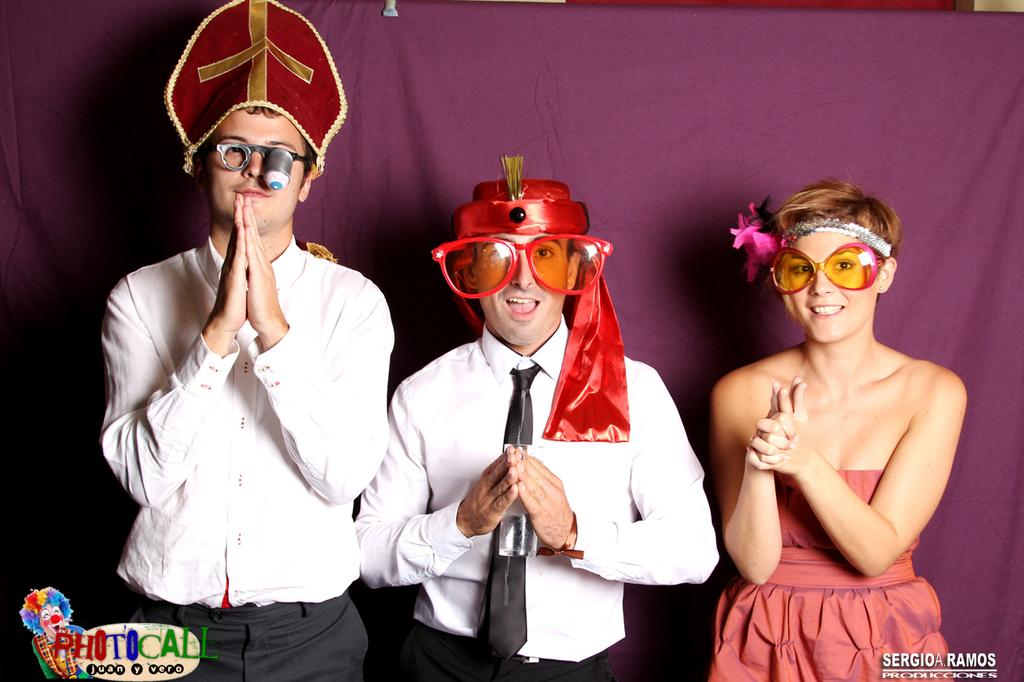How many people are present in the image? There are three people in the image. What do all three people have in common? All three people are wearing glasses. What is one of the men holding in the image? One of the men is holding a glass. What can be seen in the background of the image? There is a curtain visible in the background of the image. What type of fish can be seen participating in the activity in the image? There are no fish or activities involving fish present in the image. What key is used to unlock the door in the image? There is no door or key present in the image. 